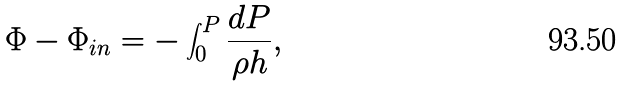<formula> <loc_0><loc_0><loc_500><loc_500>\Phi - \Phi _ { i n } = - \int ^ { P } _ { 0 } \frac { d P } { \rho h } ,</formula> 